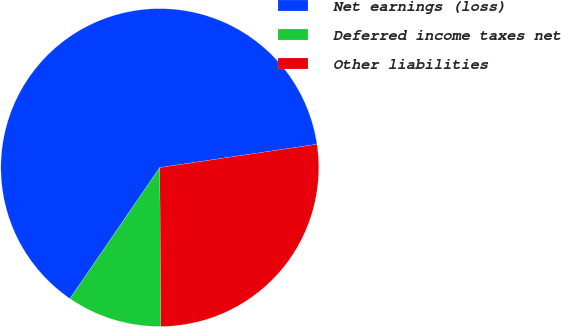<chart> <loc_0><loc_0><loc_500><loc_500><pie_chart><fcel>Net earnings (loss)<fcel>Deferred income taxes net<fcel>Other liabilities<nl><fcel>63.1%<fcel>9.67%<fcel>27.23%<nl></chart> 